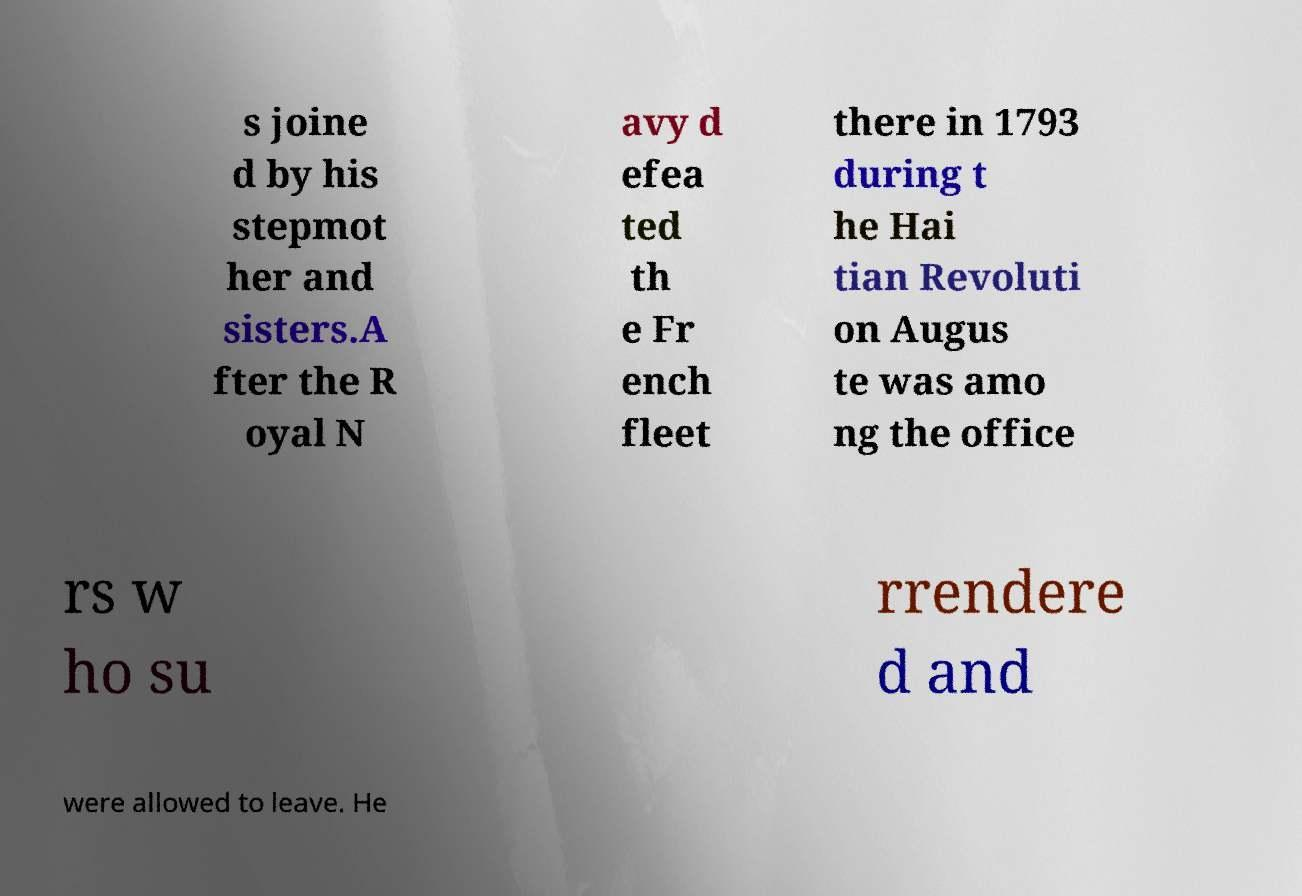Can you read and provide the text displayed in the image?This photo seems to have some interesting text. Can you extract and type it out for me? s joine d by his stepmot her and sisters.A fter the R oyal N avy d efea ted th e Fr ench fleet there in 1793 during t he Hai tian Revoluti on Augus te was amo ng the office rs w ho su rrendere d and were allowed to leave. He 